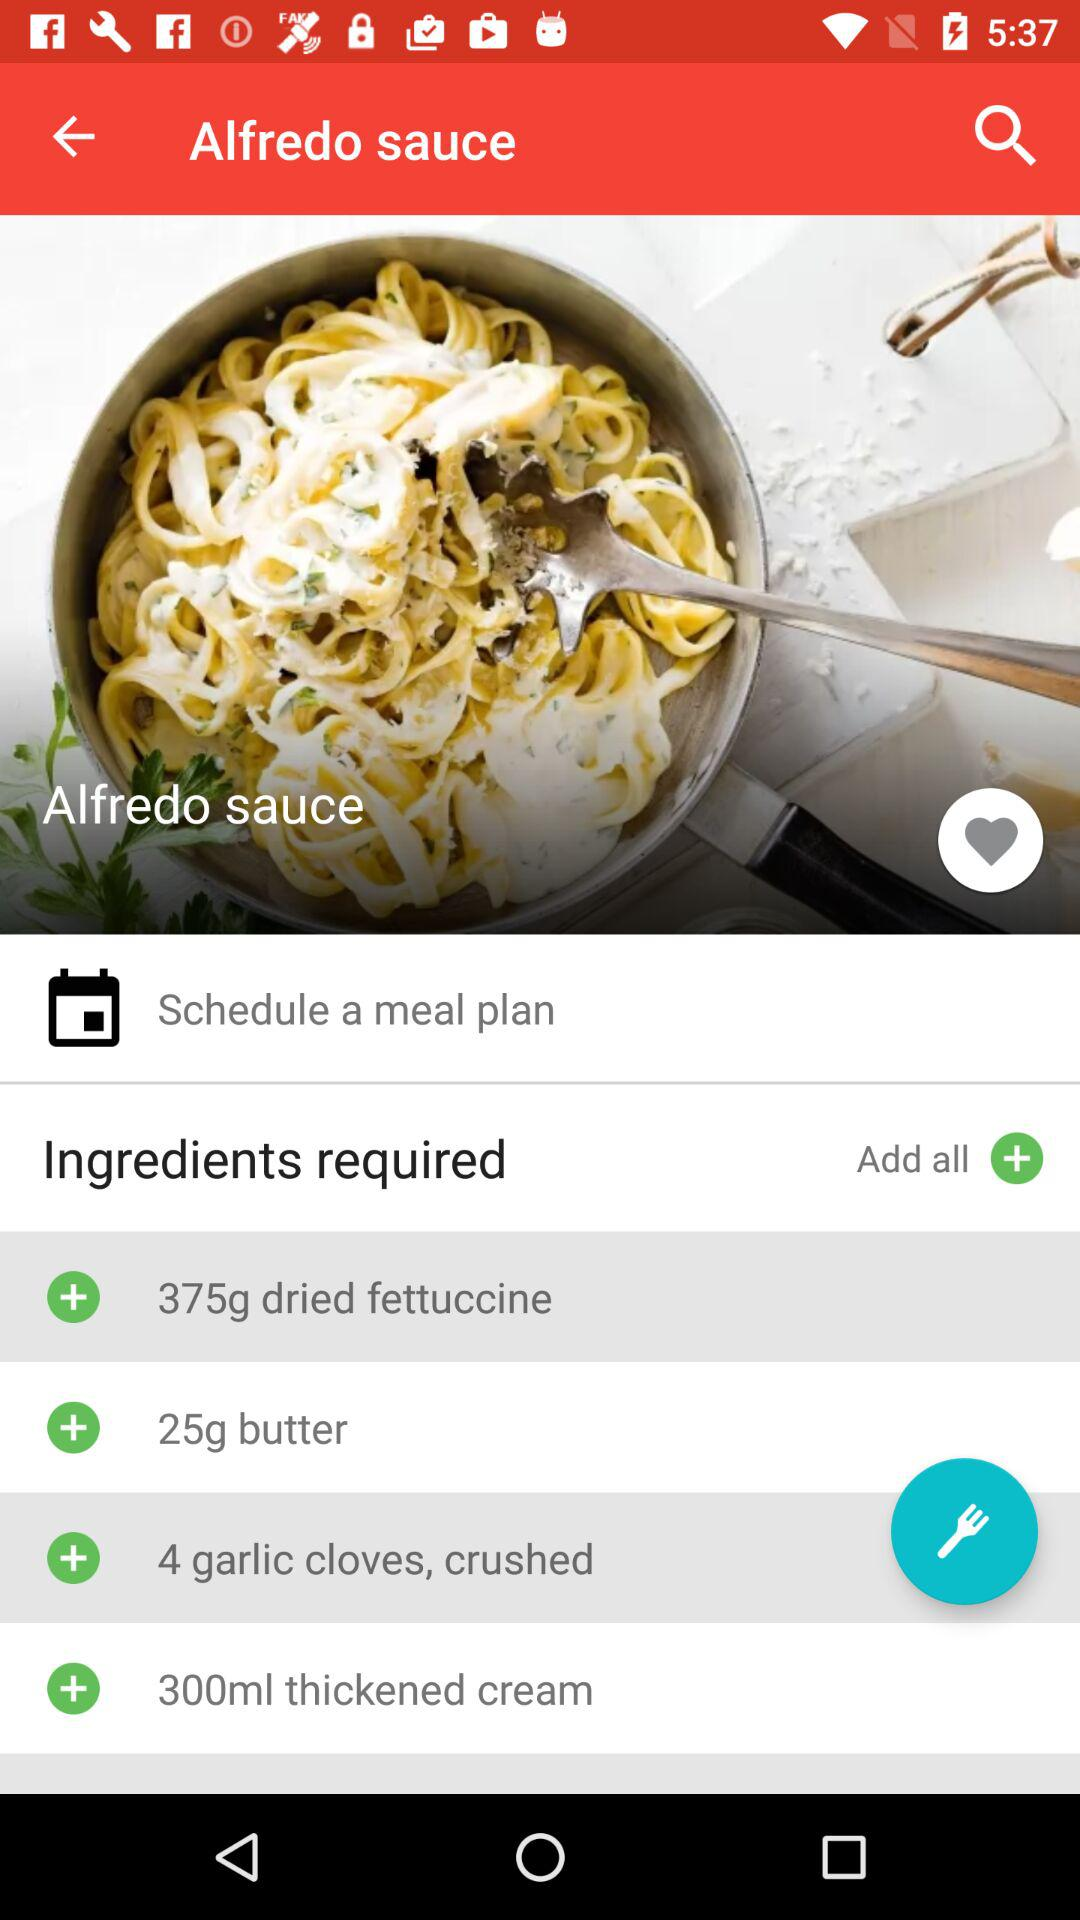What is the dish name? The dish name is "Alfredo sauce". 